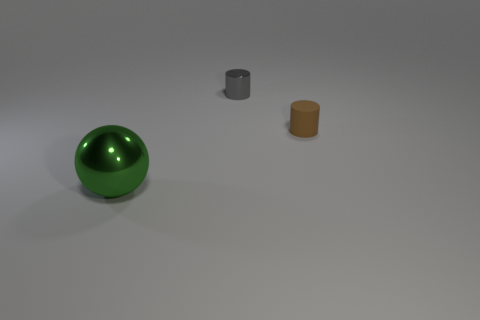What number of objects are in front of the gray metallic cylinder and to the left of the rubber thing?
Give a very brief answer. 1. Is the rubber thing the same size as the green object?
Offer a terse response. No. Does the object that is behind the rubber thing have the same size as the rubber cylinder?
Your answer should be compact. Yes. What color is the shiny object behind the large green shiny ball?
Provide a succinct answer. Gray. How many gray cylinders are there?
Make the answer very short. 1. There is a large green thing that is the same material as the gray thing; what shape is it?
Keep it short and to the point. Sphere. Are there the same number of big metallic objects that are in front of the large thing and big blue balls?
Your answer should be very brief. Yes. How many large green shiny objects are to the right of the large ball?
Offer a very short reply. 0. The gray cylinder is what size?
Offer a terse response. Small. What color is the large sphere that is the same material as the tiny gray thing?
Give a very brief answer. Green. 